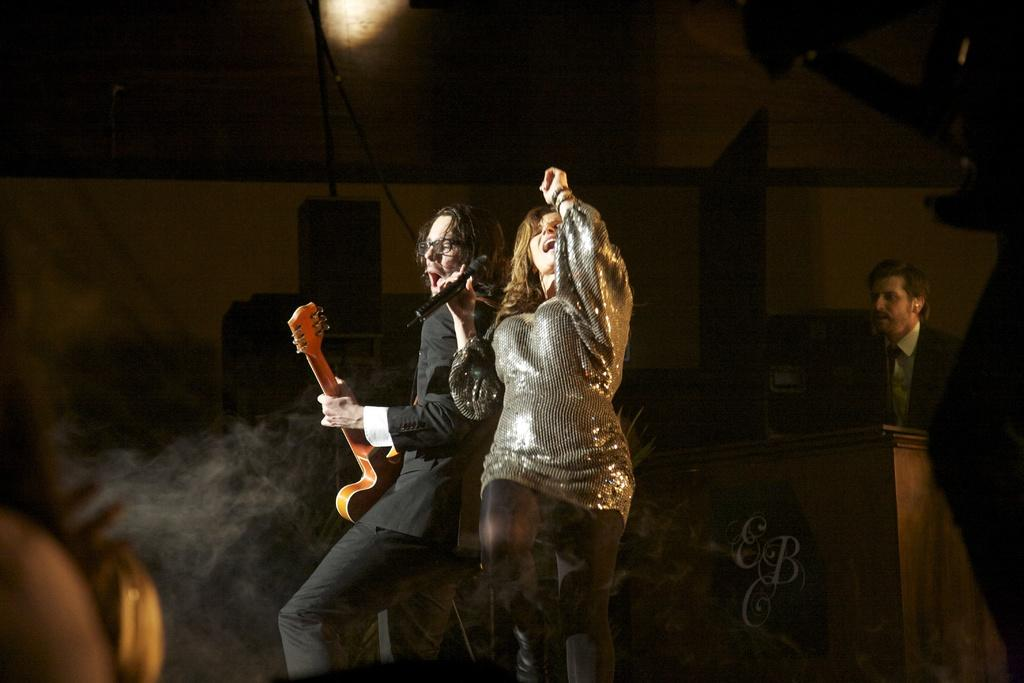What is the man in the image doing? The man is playing a guitar in the image. What are the woman and the man doing together? The woman is singing and dancing in the image. Is there anyone else in the image besides the man and the woman? Yes, there is a man watching the other two people in the image. What type of current can be seen flowing through the playground in the image? There is no playground or current present in the image; it features a man playing a guitar, a woman singing and dancing, and another man watching them. 